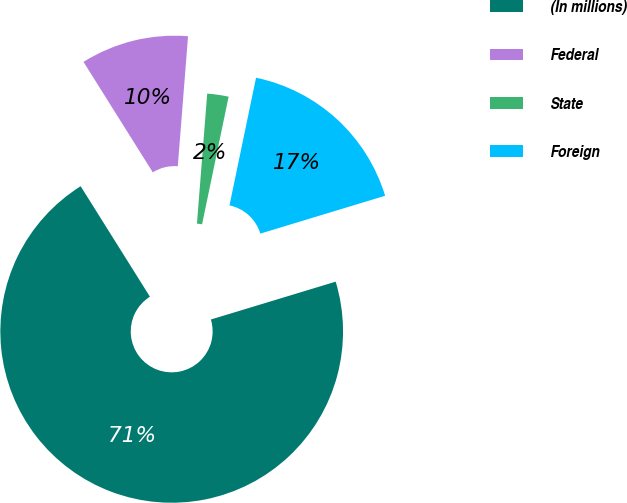Convert chart to OTSL. <chart><loc_0><loc_0><loc_500><loc_500><pie_chart><fcel>(In millions)<fcel>Federal<fcel>State<fcel>Foreign<nl><fcel>70.77%<fcel>10.17%<fcel>2.01%<fcel>17.05%<nl></chart> 